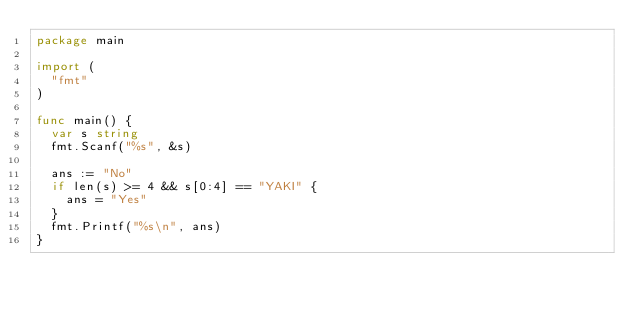<code> <loc_0><loc_0><loc_500><loc_500><_Go_>package main
 
import (
  "fmt"
)
 
func main() {
  var s string
  fmt.Scanf("%s", &s)
  
  ans := "No"
  if len(s) >= 4 && s[0:4] == "YAKI" {
    ans = "Yes"
  }
  fmt.Printf("%s\n", ans)
}</code> 